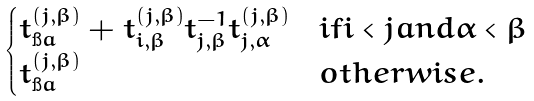<formula> <loc_0><loc_0><loc_500><loc_500>\begin{cases} t _ { \i a } ^ { ( j , \beta ) } + t _ { i , \beta } ^ { ( j , \beta ) } t _ { j , \beta } ^ { - 1 } t _ { j , \alpha } ^ { ( j , \beta ) } & i f i < j a n d \alpha < \beta \\ t _ { \i a } ^ { ( j , \beta ) } & o t h e r w i s e . \end{cases}</formula> 